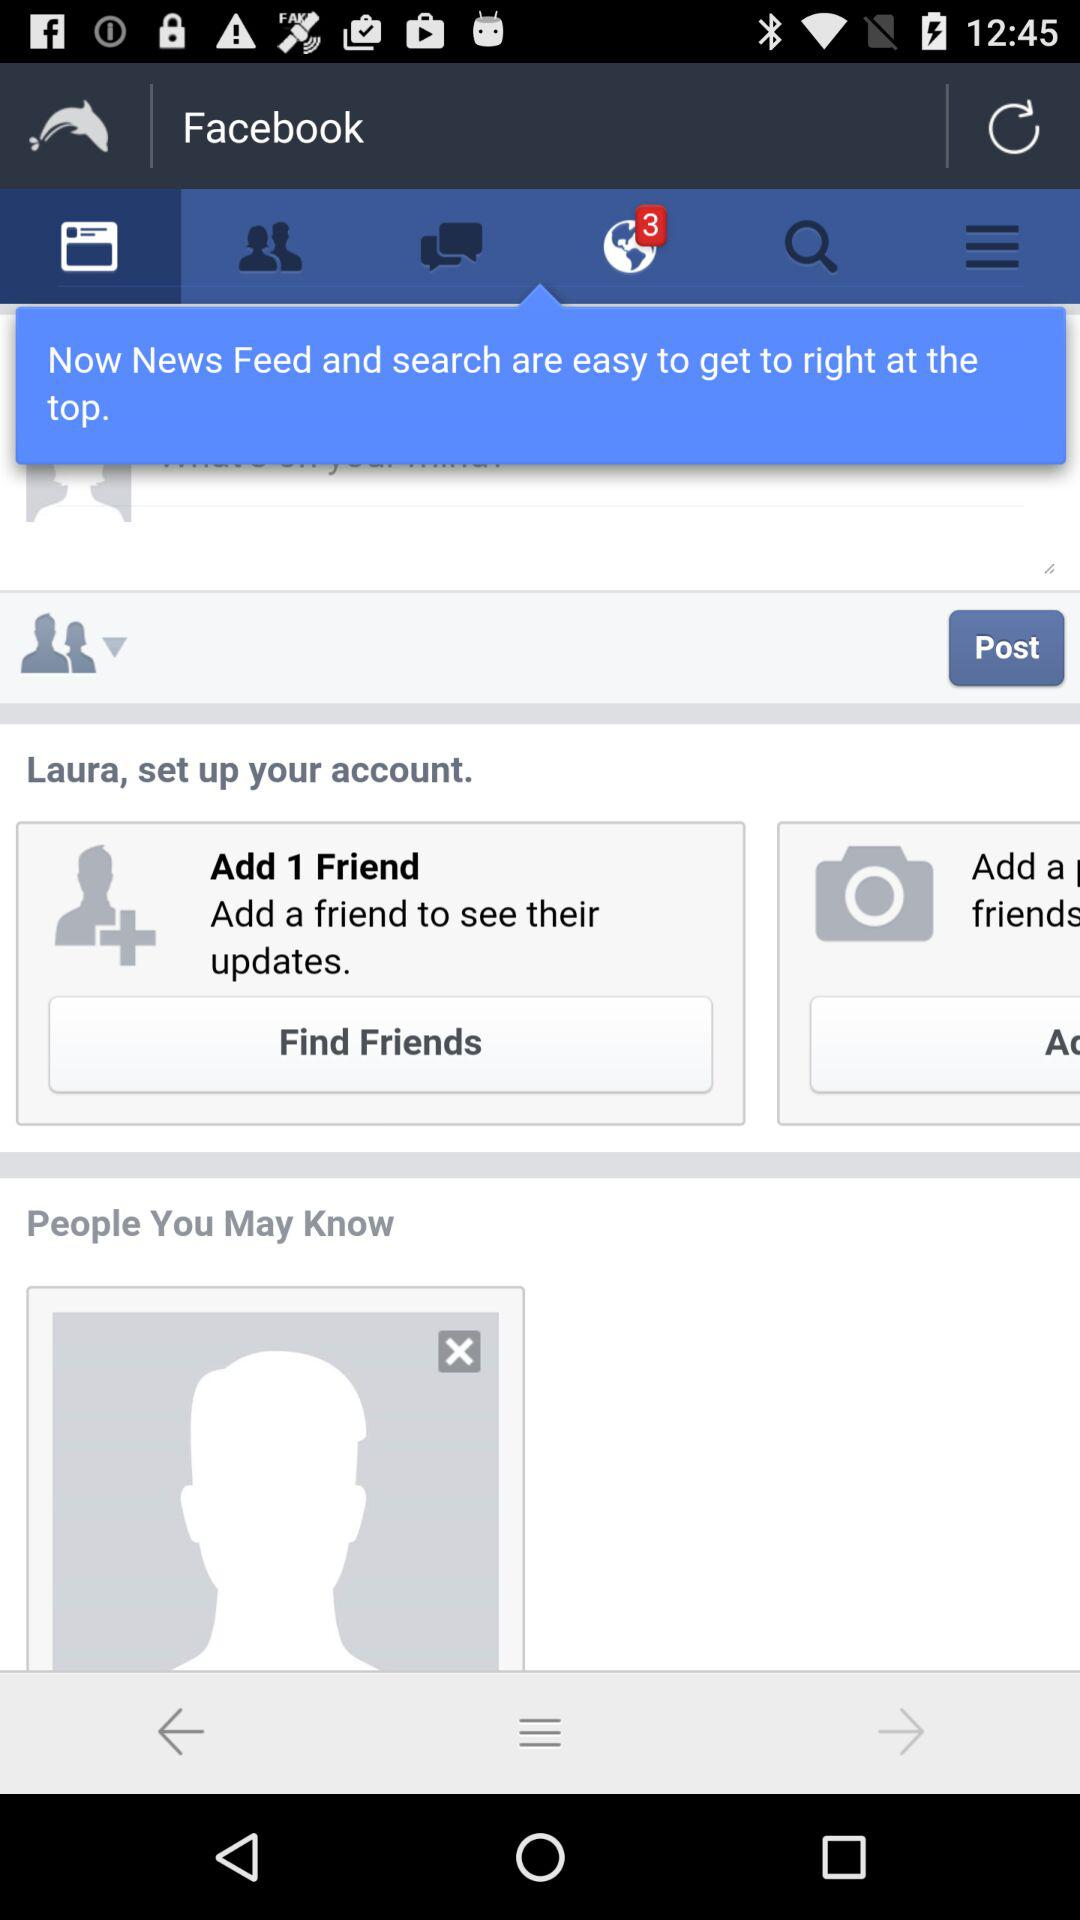How many contacts are there?
When the provided information is insufficient, respond with <no answer>. <no answer> 